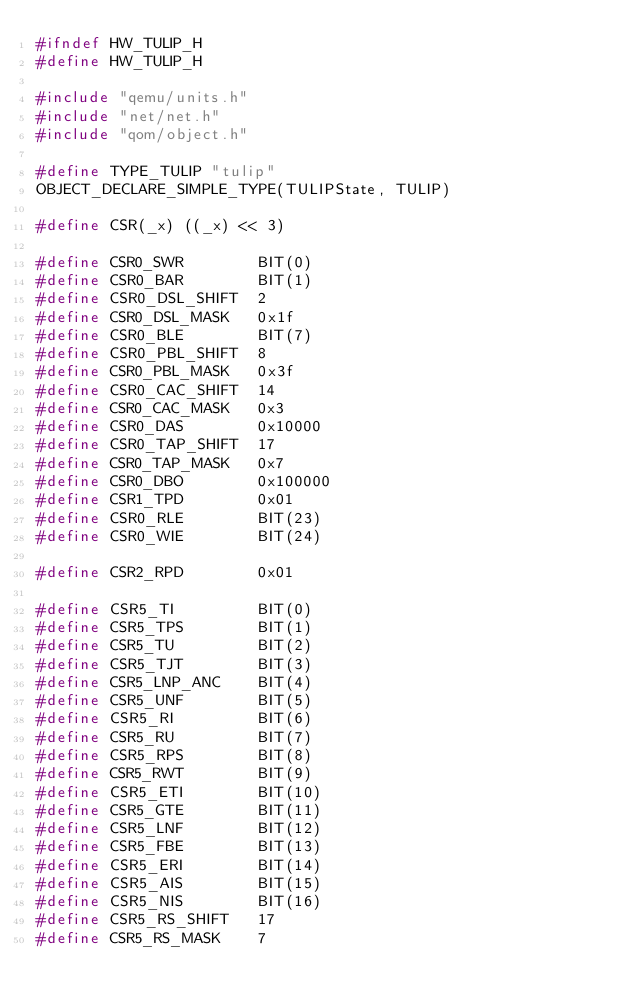<code> <loc_0><loc_0><loc_500><loc_500><_C_>#ifndef HW_TULIP_H
#define HW_TULIP_H

#include "qemu/units.h"
#include "net/net.h"
#include "qom/object.h"

#define TYPE_TULIP "tulip"
OBJECT_DECLARE_SIMPLE_TYPE(TULIPState, TULIP)

#define CSR(_x) ((_x) << 3)

#define CSR0_SWR        BIT(0)
#define CSR0_BAR        BIT(1)
#define CSR0_DSL_SHIFT  2
#define CSR0_DSL_MASK   0x1f
#define CSR0_BLE        BIT(7)
#define CSR0_PBL_SHIFT  8
#define CSR0_PBL_MASK   0x3f
#define CSR0_CAC_SHIFT  14
#define CSR0_CAC_MASK   0x3
#define CSR0_DAS        0x10000
#define CSR0_TAP_SHIFT  17
#define CSR0_TAP_MASK   0x7
#define CSR0_DBO        0x100000
#define CSR1_TPD        0x01
#define CSR0_RLE        BIT(23)
#define CSR0_WIE        BIT(24)

#define CSR2_RPD        0x01

#define CSR5_TI         BIT(0)
#define CSR5_TPS        BIT(1)
#define CSR5_TU         BIT(2)
#define CSR5_TJT        BIT(3)
#define CSR5_LNP_ANC    BIT(4)
#define CSR5_UNF        BIT(5)
#define CSR5_RI         BIT(6)
#define CSR5_RU         BIT(7)
#define CSR5_RPS        BIT(8)
#define CSR5_RWT        BIT(9)
#define CSR5_ETI        BIT(10)
#define CSR5_GTE        BIT(11)
#define CSR5_LNF        BIT(12)
#define CSR5_FBE        BIT(13)
#define CSR5_ERI        BIT(14)
#define CSR5_AIS        BIT(15)
#define CSR5_NIS        BIT(16)
#define CSR5_RS_SHIFT   17
#define CSR5_RS_MASK    7</code> 